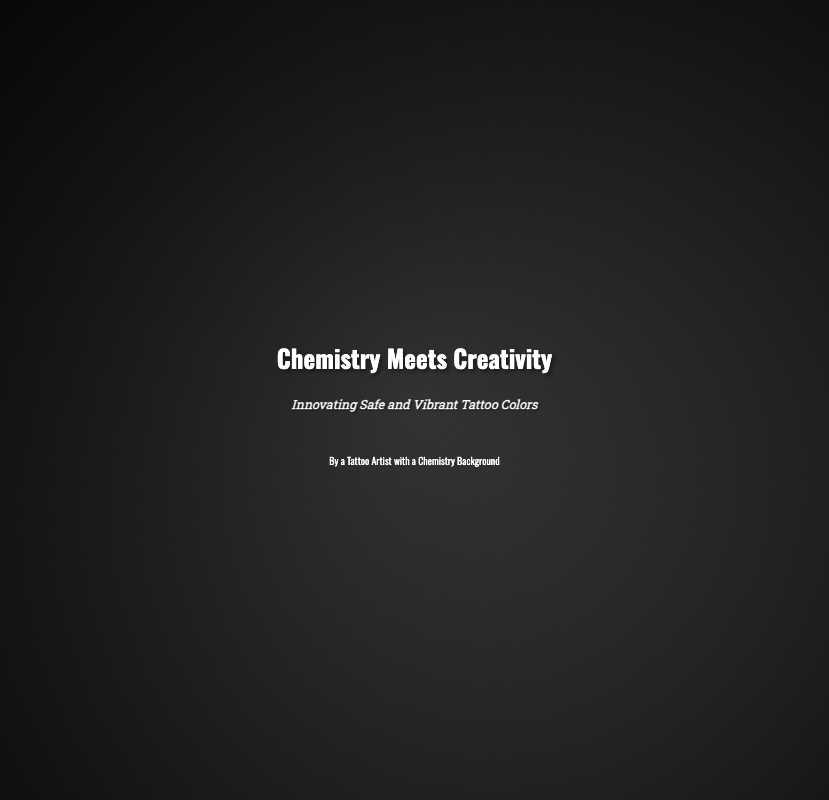What is the book title? The title of the book is highlighted prominently on the cover.
Answer: Chemistry Meets Creativity What is the subtitle of the book? The subtitle provides additional context about the book's focus.
Answer: Innovating Safe and Vibrant Tattoo Colors Who is the author? The author's description is displayed below the subtitle on the cover.
Answer: By a Tattoo Artist with a Chemistry Background What is the background color of the book cover? The background color is specified in the style of the document.
Answer: Dark gradient How many images are used in the cover design? The cover incorporates two distinct images relevant to the theme.
Answer: Two What style of font is used for the title? The font style for the title is mentioned in the CSS styles of the document.
Answer: Oswald What is the font size for the subtitle? The subtitle's font size is defined in the style attributes of the text.
Answer: 1.5vw What is the primary theme of the book? The theme combines elements from tattoo artistry and scientific principles.
Answer: Tattoo colors What visual elements symbolize the fusion of science and art? The cover design includes imagery that embodies both disciplines.
Answer: Chemical apparatus and ink droplets What effect is used on the images in the cover? The cover utilizes a specific visual technique to enhance the overall appearance.
Answer: Blur effect 